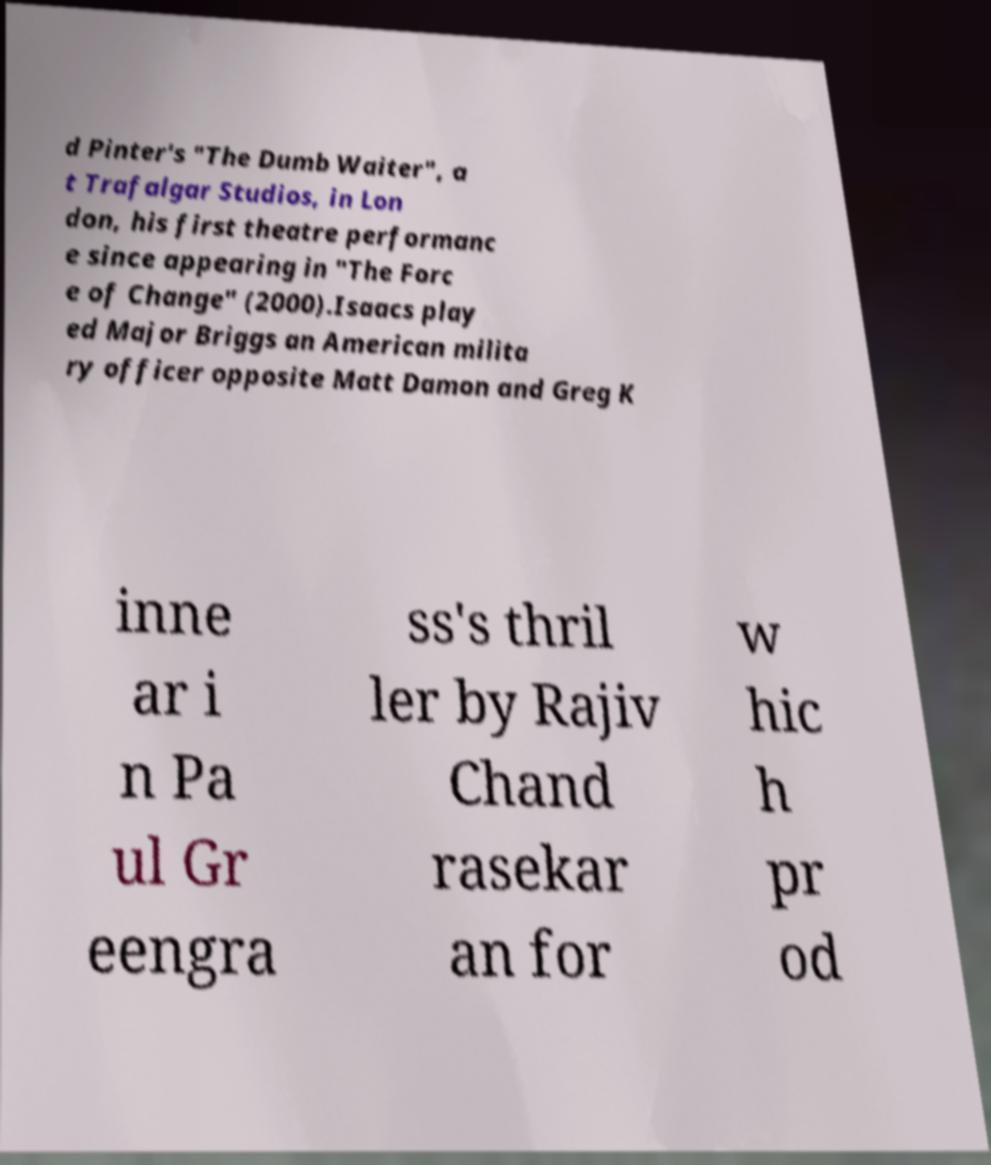Could you assist in decoding the text presented in this image and type it out clearly? d Pinter's "The Dumb Waiter", a t Trafalgar Studios, in Lon don, his first theatre performanc e since appearing in "The Forc e of Change" (2000).Isaacs play ed Major Briggs an American milita ry officer opposite Matt Damon and Greg K inne ar i n Pa ul Gr eengra ss's thril ler by Rajiv Chand rasekar an for w hic h pr od 